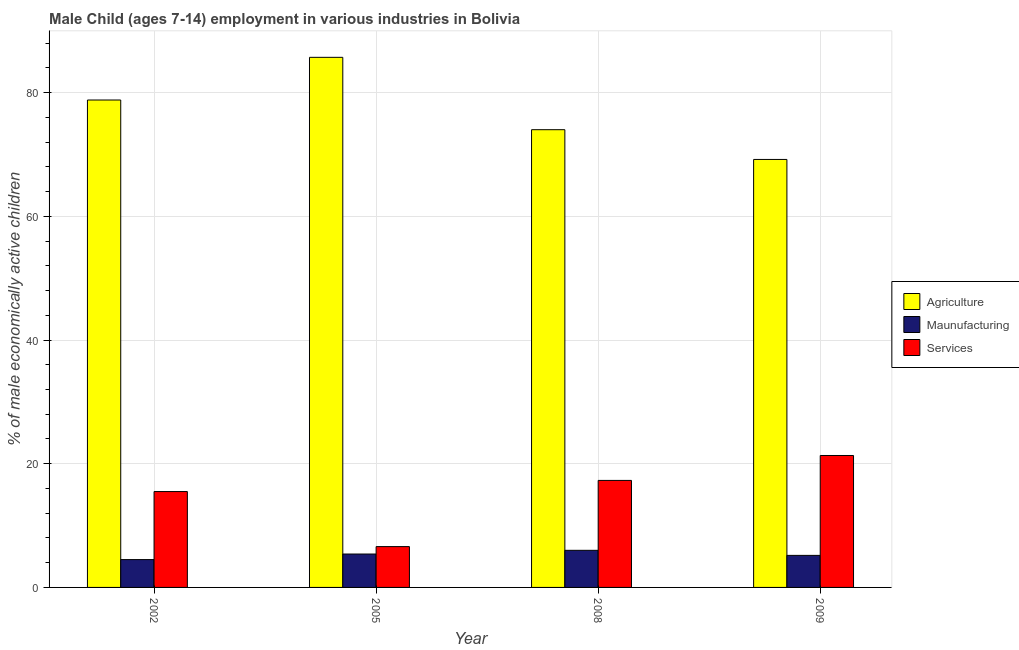How many different coloured bars are there?
Give a very brief answer. 3. How many bars are there on the 4th tick from the right?
Your answer should be very brief. 3. In how many cases, is the number of bars for a given year not equal to the number of legend labels?
Ensure brevity in your answer.  0. What is the percentage of economically active children in manufacturing in 2009?
Your response must be concise. 5.18. Across all years, what is the maximum percentage of economically active children in agriculture?
Keep it short and to the point. 85.7. Across all years, what is the minimum percentage of economically active children in agriculture?
Your response must be concise. 69.19. In which year was the percentage of economically active children in services minimum?
Make the answer very short. 2005. What is the total percentage of economically active children in agriculture in the graph?
Keep it short and to the point. 307.69. What is the difference between the percentage of economically active children in services in 2005 and that in 2009?
Offer a terse response. -14.73. What is the difference between the percentage of economically active children in services in 2008 and the percentage of economically active children in manufacturing in 2005?
Keep it short and to the point. 10.7. What is the average percentage of economically active children in services per year?
Offer a terse response. 15.18. In how many years, is the percentage of economically active children in agriculture greater than 24 %?
Offer a very short reply. 4. What is the ratio of the percentage of economically active children in agriculture in 2002 to that in 2008?
Provide a succinct answer. 1.06. Is the percentage of economically active children in services in 2002 less than that in 2008?
Your response must be concise. Yes. Is the difference between the percentage of economically active children in services in 2002 and 2005 greater than the difference between the percentage of economically active children in manufacturing in 2002 and 2005?
Give a very brief answer. No. What is the difference between the highest and the second highest percentage of economically active children in services?
Provide a short and direct response. 4.03. What is the difference between the highest and the lowest percentage of economically active children in manufacturing?
Ensure brevity in your answer.  1.5. Is the sum of the percentage of economically active children in services in 2002 and 2009 greater than the maximum percentage of economically active children in agriculture across all years?
Offer a terse response. Yes. What does the 3rd bar from the left in 2008 represents?
Offer a terse response. Services. What does the 2nd bar from the right in 2002 represents?
Your response must be concise. Maunufacturing. Is it the case that in every year, the sum of the percentage of economically active children in agriculture and percentage of economically active children in manufacturing is greater than the percentage of economically active children in services?
Provide a short and direct response. Yes. How many bars are there?
Provide a succinct answer. 12. Are all the bars in the graph horizontal?
Your answer should be compact. No. How many years are there in the graph?
Keep it short and to the point. 4. What is the difference between two consecutive major ticks on the Y-axis?
Provide a succinct answer. 20. Does the graph contain grids?
Your answer should be compact. Yes. How are the legend labels stacked?
Your answer should be compact. Vertical. What is the title of the graph?
Give a very brief answer. Male Child (ages 7-14) employment in various industries in Bolivia. What is the label or title of the Y-axis?
Provide a succinct answer. % of male economically active children. What is the % of male economically active children of Agriculture in 2002?
Your response must be concise. 78.8. What is the % of male economically active children of Maunufacturing in 2002?
Provide a short and direct response. 4.5. What is the % of male economically active children of Services in 2002?
Provide a short and direct response. 15.5. What is the % of male economically active children of Agriculture in 2005?
Your response must be concise. 85.7. What is the % of male economically active children of Maunufacturing in 2005?
Provide a succinct answer. 5.4. What is the % of male economically active children in Services in 2005?
Give a very brief answer. 6.6. What is the % of male economically active children of Agriculture in 2008?
Make the answer very short. 74. What is the % of male economically active children of Maunufacturing in 2008?
Offer a terse response. 6. What is the % of male economically active children in Services in 2008?
Your answer should be compact. 17.3. What is the % of male economically active children in Agriculture in 2009?
Provide a succinct answer. 69.19. What is the % of male economically active children of Maunufacturing in 2009?
Offer a terse response. 5.18. What is the % of male economically active children of Services in 2009?
Your answer should be very brief. 21.33. Across all years, what is the maximum % of male economically active children in Agriculture?
Keep it short and to the point. 85.7. Across all years, what is the maximum % of male economically active children of Services?
Provide a succinct answer. 21.33. Across all years, what is the minimum % of male economically active children in Agriculture?
Make the answer very short. 69.19. Across all years, what is the minimum % of male economically active children of Maunufacturing?
Keep it short and to the point. 4.5. What is the total % of male economically active children of Agriculture in the graph?
Keep it short and to the point. 307.69. What is the total % of male economically active children in Maunufacturing in the graph?
Provide a short and direct response. 21.08. What is the total % of male economically active children of Services in the graph?
Ensure brevity in your answer.  60.73. What is the difference between the % of male economically active children of Agriculture in 2002 and that in 2005?
Ensure brevity in your answer.  -6.9. What is the difference between the % of male economically active children in Maunufacturing in 2002 and that in 2005?
Offer a terse response. -0.9. What is the difference between the % of male economically active children of Services in 2002 and that in 2005?
Give a very brief answer. 8.9. What is the difference between the % of male economically active children in Services in 2002 and that in 2008?
Offer a terse response. -1.8. What is the difference between the % of male economically active children in Agriculture in 2002 and that in 2009?
Your answer should be compact. 9.61. What is the difference between the % of male economically active children in Maunufacturing in 2002 and that in 2009?
Provide a succinct answer. -0.68. What is the difference between the % of male economically active children in Services in 2002 and that in 2009?
Make the answer very short. -5.83. What is the difference between the % of male economically active children in Agriculture in 2005 and that in 2008?
Give a very brief answer. 11.7. What is the difference between the % of male economically active children of Maunufacturing in 2005 and that in 2008?
Offer a very short reply. -0.6. What is the difference between the % of male economically active children in Agriculture in 2005 and that in 2009?
Your answer should be very brief. 16.51. What is the difference between the % of male economically active children of Maunufacturing in 2005 and that in 2009?
Provide a succinct answer. 0.22. What is the difference between the % of male economically active children in Services in 2005 and that in 2009?
Provide a succinct answer. -14.73. What is the difference between the % of male economically active children in Agriculture in 2008 and that in 2009?
Make the answer very short. 4.81. What is the difference between the % of male economically active children of Maunufacturing in 2008 and that in 2009?
Offer a terse response. 0.82. What is the difference between the % of male economically active children in Services in 2008 and that in 2009?
Ensure brevity in your answer.  -4.03. What is the difference between the % of male economically active children in Agriculture in 2002 and the % of male economically active children in Maunufacturing in 2005?
Offer a very short reply. 73.4. What is the difference between the % of male economically active children of Agriculture in 2002 and the % of male economically active children of Services in 2005?
Keep it short and to the point. 72.2. What is the difference between the % of male economically active children in Agriculture in 2002 and the % of male economically active children in Maunufacturing in 2008?
Ensure brevity in your answer.  72.8. What is the difference between the % of male economically active children in Agriculture in 2002 and the % of male economically active children in Services in 2008?
Offer a terse response. 61.5. What is the difference between the % of male economically active children of Maunufacturing in 2002 and the % of male economically active children of Services in 2008?
Offer a terse response. -12.8. What is the difference between the % of male economically active children of Agriculture in 2002 and the % of male economically active children of Maunufacturing in 2009?
Keep it short and to the point. 73.62. What is the difference between the % of male economically active children in Agriculture in 2002 and the % of male economically active children in Services in 2009?
Your answer should be compact. 57.47. What is the difference between the % of male economically active children in Maunufacturing in 2002 and the % of male economically active children in Services in 2009?
Ensure brevity in your answer.  -16.83. What is the difference between the % of male economically active children in Agriculture in 2005 and the % of male economically active children in Maunufacturing in 2008?
Provide a succinct answer. 79.7. What is the difference between the % of male economically active children of Agriculture in 2005 and the % of male economically active children of Services in 2008?
Offer a very short reply. 68.4. What is the difference between the % of male economically active children in Maunufacturing in 2005 and the % of male economically active children in Services in 2008?
Provide a short and direct response. -11.9. What is the difference between the % of male economically active children of Agriculture in 2005 and the % of male economically active children of Maunufacturing in 2009?
Provide a succinct answer. 80.52. What is the difference between the % of male economically active children in Agriculture in 2005 and the % of male economically active children in Services in 2009?
Provide a succinct answer. 64.37. What is the difference between the % of male economically active children in Maunufacturing in 2005 and the % of male economically active children in Services in 2009?
Offer a terse response. -15.93. What is the difference between the % of male economically active children in Agriculture in 2008 and the % of male economically active children in Maunufacturing in 2009?
Your response must be concise. 68.82. What is the difference between the % of male economically active children of Agriculture in 2008 and the % of male economically active children of Services in 2009?
Give a very brief answer. 52.67. What is the difference between the % of male economically active children in Maunufacturing in 2008 and the % of male economically active children in Services in 2009?
Offer a very short reply. -15.33. What is the average % of male economically active children of Agriculture per year?
Offer a terse response. 76.92. What is the average % of male economically active children of Maunufacturing per year?
Make the answer very short. 5.27. What is the average % of male economically active children of Services per year?
Your answer should be compact. 15.18. In the year 2002, what is the difference between the % of male economically active children in Agriculture and % of male economically active children in Maunufacturing?
Ensure brevity in your answer.  74.3. In the year 2002, what is the difference between the % of male economically active children in Agriculture and % of male economically active children in Services?
Your answer should be compact. 63.3. In the year 2005, what is the difference between the % of male economically active children in Agriculture and % of male economically active children in Maunufacturing?
Provide a short and direct response. 80.3. In the year 2005, what is the difference between the % of male economically active children of Agriculture and % of male economically active children of Services?
Offer a terse response. 79.1. In the year 2008, what is the difference between the % of male economically active children of Agriculture and % of male economically active children of Maunufacturing?
Offer a very short reply. 68. In the year 2008, what is the difference between the % of male economically active children in Agriculture and % of male economically active children in Services?
Provide a succinct answer. 56.7. In the year 2008, what is the difference between the % of male economically active children of Maunufacturing and % of male economically active children of Services?
Provide a succinct answer. -11.3. In the year 2009, what is the difference between the % of male economically active children in Agriculture and % of male economically active children in Maunufacturing?
Offer a terse response. 64.01. In the year 2009, what is the difference between the % of male economically active children of Agriculture and % of male economically active children of Services?
Make the answer very short. 47.86. In the year 2009, what is the difference between the % of male economically active children of Maunufacturing and % of male economically active children of Services?
Ensure brevity in your answer.  -16.15. What is the ratio of the % of male economically active children in Agriculture in 2002 to that in 2005?
Make the answer very short. 0.92. What is the ratio of the % of male economically active children in Maunufacturing in 2002 to that in 2005?
Offer a terse response. 0.83. What is the ratio of the % of male economically active children in Services in 2002 to that in 2005?
Give a very brief answer. 2.35. What is the ratio of the % of male economically active children in Agriculture in 2002 to that in 2008?
Provide a short and direct response. 1.06. What is the ratio of the % of male economically active children of Maunufacturing in 2002 to that in 2008?
Provide a succinct answer. 0.75. What is the ratio of the % of male economically active children of Services in 2002 to that in 2008?
Make the answer very short. 0.9. What is the ratio of the % of male economically active children of Agriculture in 2002 to that in 2009?
Give a very brief answer. 1.14. What is the ratio of the % of male economically active children of Maunufacturing in 2002 to that in 2009?
Ensure brevity in your answer.  0.87. What is the ratio of the % of male economically active children of Services in 2002 to that in 2009?
Your answer should be compact. 0.73. What is the ratio of the % of male economically active children in Agriculture in 2005 to that in 2008?
Provide a short and direct response. 1.16. What is the ratio of the % of male economically active children of Maunufacturing in 2005 to that in 2008?
Make the answer very short. 0.9. What is the ratio of the % of male economically active children in Services in 2005 to that in 2008?
Offer a very short reply. 0.38. What is the ratio of the % of male economically active children of Agriculture in 2005 to that in 2009?
Make the answer very short. 1.24. What is the ratio of the % of male economically active children of Maunufacturing in 2005 to that in 2009?
Your response must be concise. 1.04. What is the ratio of the % of male economically active children in Services in 2005 to that in 2009?
Offer a terse response. 0.31. What is the ratio of the % of male economically active children of Agriculture in 2008 to that in 2009?
Your answer should be very brief. 1.07. What is the ratio of the % of male economically active children of Maunufacturing in 2008 to that in 2009?
Give a very brief answer. 1.16. What is the ratio of the % of male economically active children in Services in 2008 to that in 2009?
Your answer should be very brief. 0.81. What is the difference between the highest and the second highest % of male economically active children in Maunufacturing?
Ensure brevity in your answer.  0.6. What is the difference between the highest and the second highest % of male economically active children in Services?
Ensure brevity in your answer.  4.03. What is the difference between the highest and the lowest % of male economically active children of Agriculture?
Offer a very short reply. 16.51. What is the difference between the highest and the lowest % of male economically active children of Maunufacturing?
Offer a very short reply. 1.5. What is the difference between the highest and the lowest % of male economically active children of Services?
Your answer should be very brief. 14.73. 